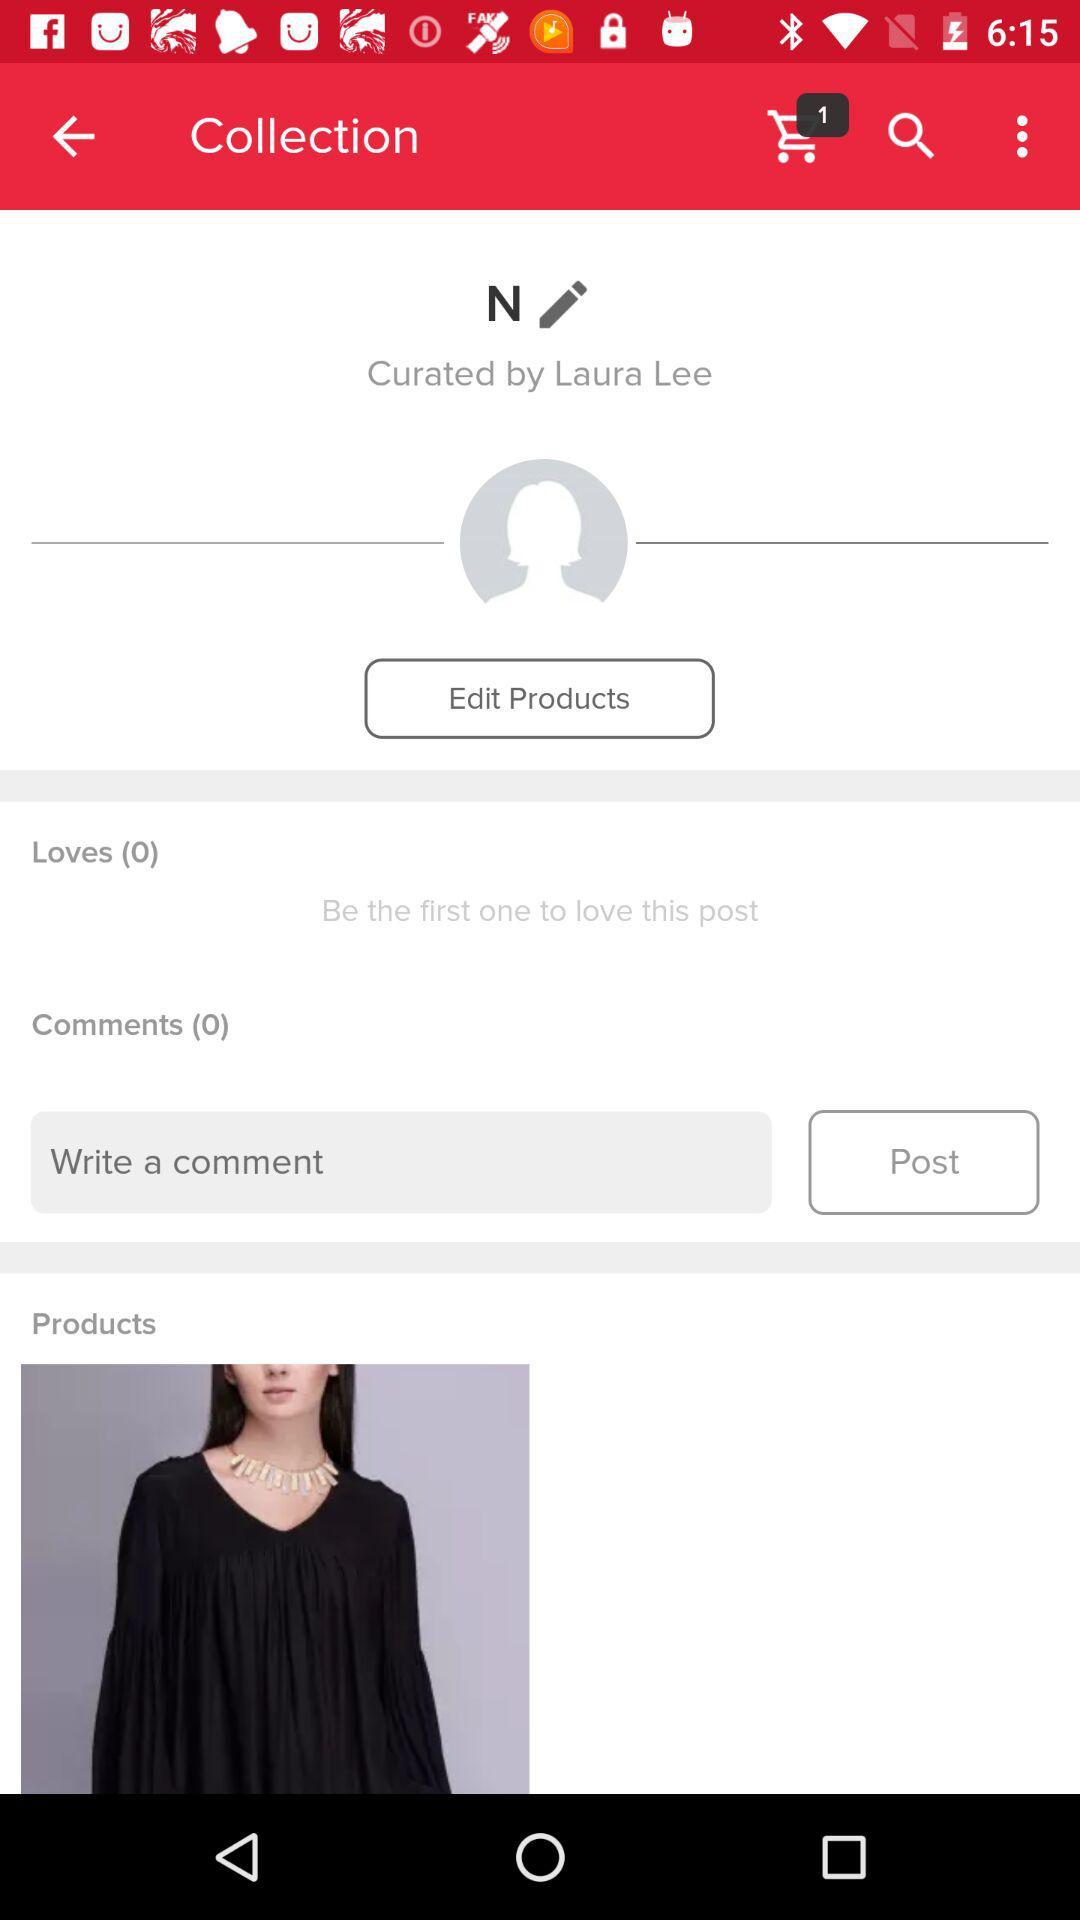What is the user name? The user name is "Laura Lee". 